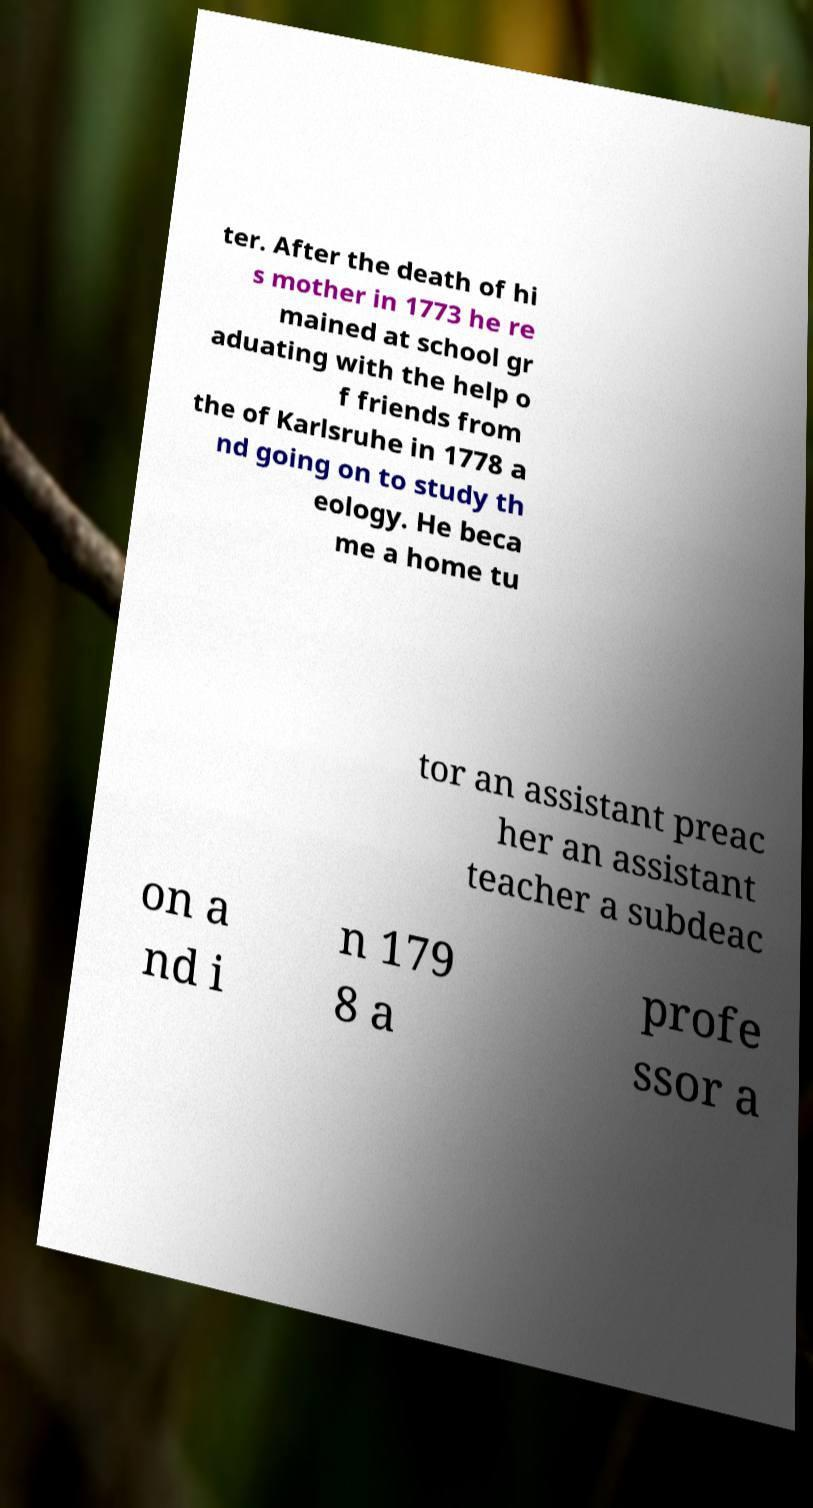I need the written content from this picture converted into text. Can you do that? ter. After the death of hi s mother in 1773 he re mained at school gr aduating with the help o f friends from the of Karlsruhe in 1778 a nd going on to study th eology. He beca me a home tu tor an assistant preac her an assistant teacher a subdeac on a nd i n 179 8 a profe ssor a 